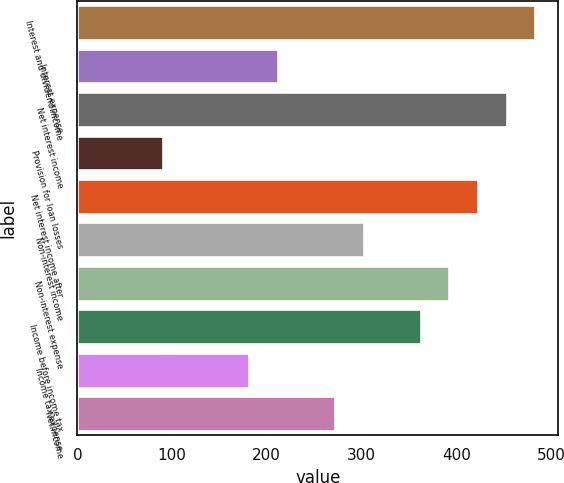Convert chart. <chart><loc_0><loc_0><loc_500><loc_500><bar_chart><fcel>Interest and dividend income<fcel>Interest expense<fcel>Net interest income<fcel>Provision for loan losses<fcel>Net interest income after<fcel>Non-interest income<fcel>Non-interest expense<fcel>Income before income tax<fcel>Income tax expense<fcel>Net income<nl><fcel>483.36<fcel>211.56<fcel>453.16<fcel>90.76<fcel>422.96<fcel>302.16<fcel>392.76<fcel>362.56<fcel>181.36<fcel>271.96<nl></chart> 